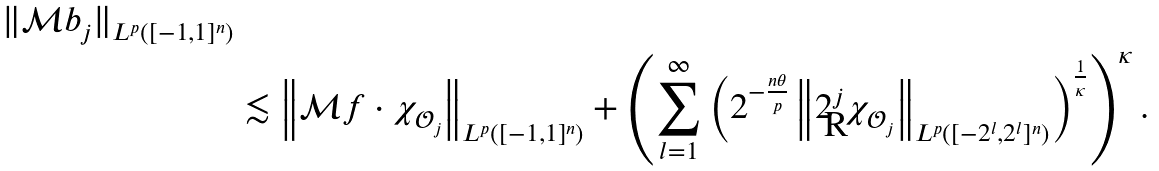<formula> <loc_0><loc_0><loc_500><loc_500>{ \| { \mathcal { M } } b _ { j } \| _ { L ^ { p } ( [ - 1 , 1 ] ^ { n } ) } } \\ & \lesssim \left \| { \mathcal { M } } f \cdot \chi _ { { \mathcal { O } } _ { j } } \right \| _ { L ^ { p } ( [ - 1 , 1 ] ^ { n } ) } + \left ( \sum _ { l = 1 } ^ { \infty } \left ( 2 ^ { - \frac { n \theta } { p } } \left \| 2 ^ { j } \chi _ { { \mathcal { O } } _ { j } } \right \| _ { L ^ { p } ( [ - 2 ^ { l } , 2 ^ { l } ] ^ { n } ) } \right ) ^ { \frac { 1 } { \kappa } } \right ) ^ { \kappa } .</formula> 